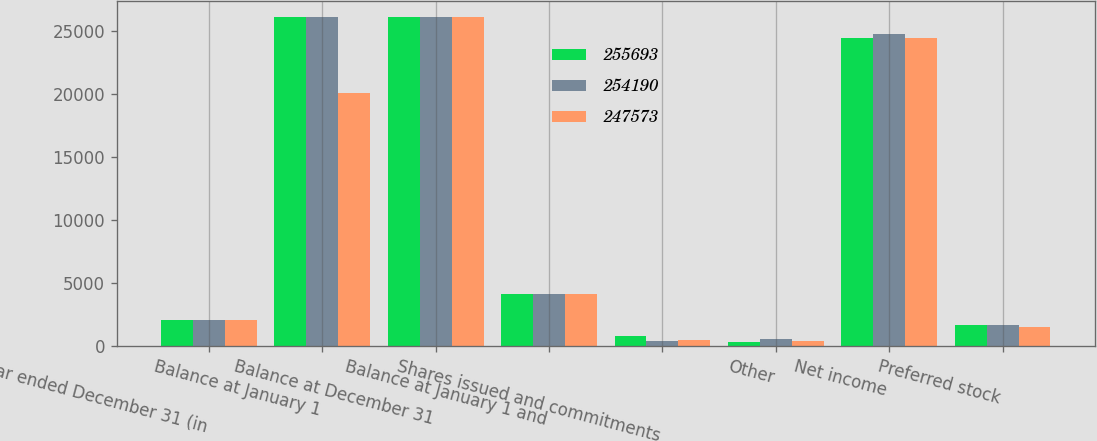Convert chart. <chart><loc_0><loc_0><loc_500><loc_500><stacked_bar_chart><ecel><fcel>Year ended December 31 (in<fcel>Balance at January 1<fcel>Balance at December 31<fcel>Balance at January 1 and<fcel>Shares issued and commitments<fcel>Other<fcel>Net income<fcel>Preferred stock<nl><fcel>255693<fcel>2017<fcel>26068<fcel>26068<fcel>4105<fcel>734<fcel>314<fcel>24441<fcel>1663<nl><fcel>254190<fcel>2016<fcel>26068<fcel>26068<fcel>4105<fcel>334<fcel>539<fcel>24733<fcel>1647<nl><fcel>247573<fcel>2015<fcel>20063<fcel>26068<fcel>4105<fcel>436<fcel>334<fcel>24442<fcel>1515<nl></chart> 